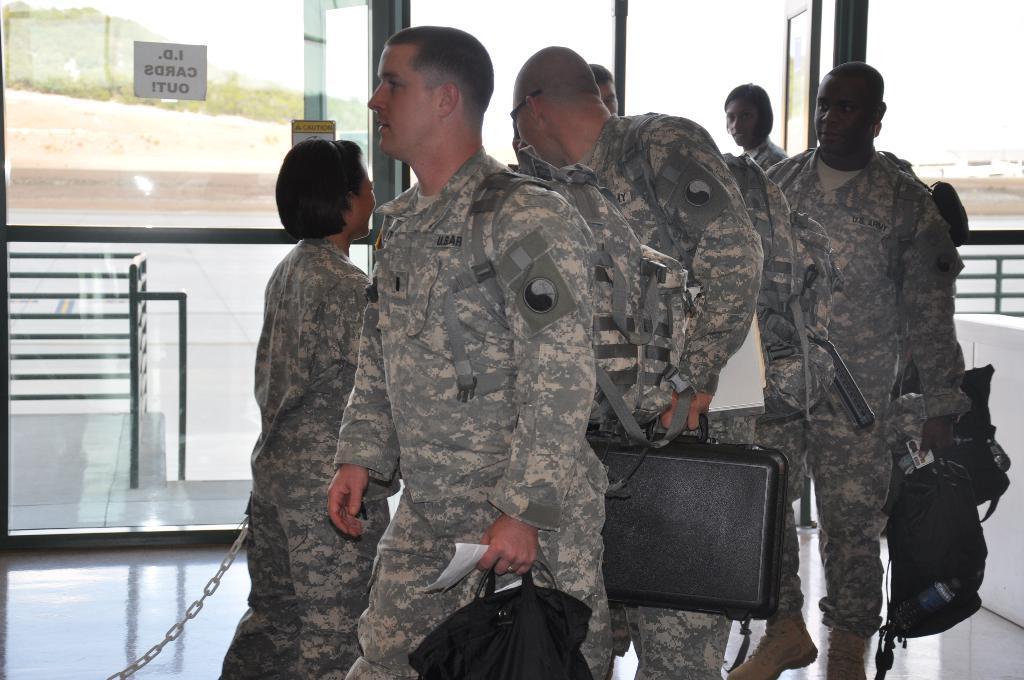Describe this image in one or two sentences. In this picture I can observe people walking on the floor. They are wearing grey color dresses and holding suitcase and bags in their hands. In the background I can observe a glass door and black color railing. 